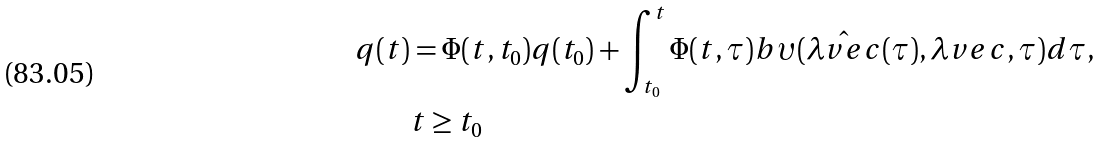Convert formula to latex. <formula><loc_0><loc_0><loc_500><loc_500>q ( t ) & = \Phi ( t , t _ { 0 } ) q ( t _ { 0 } ) + \int _ { t _ { 0 } } ^ { t } \Phi ( t , \tau ) b \upsilon ( \hat { \lambda v e c } ( \tau ) , \lambda v e c , \tau ) d \tau , \\ & t \geq t _ { 0 }</formula> 